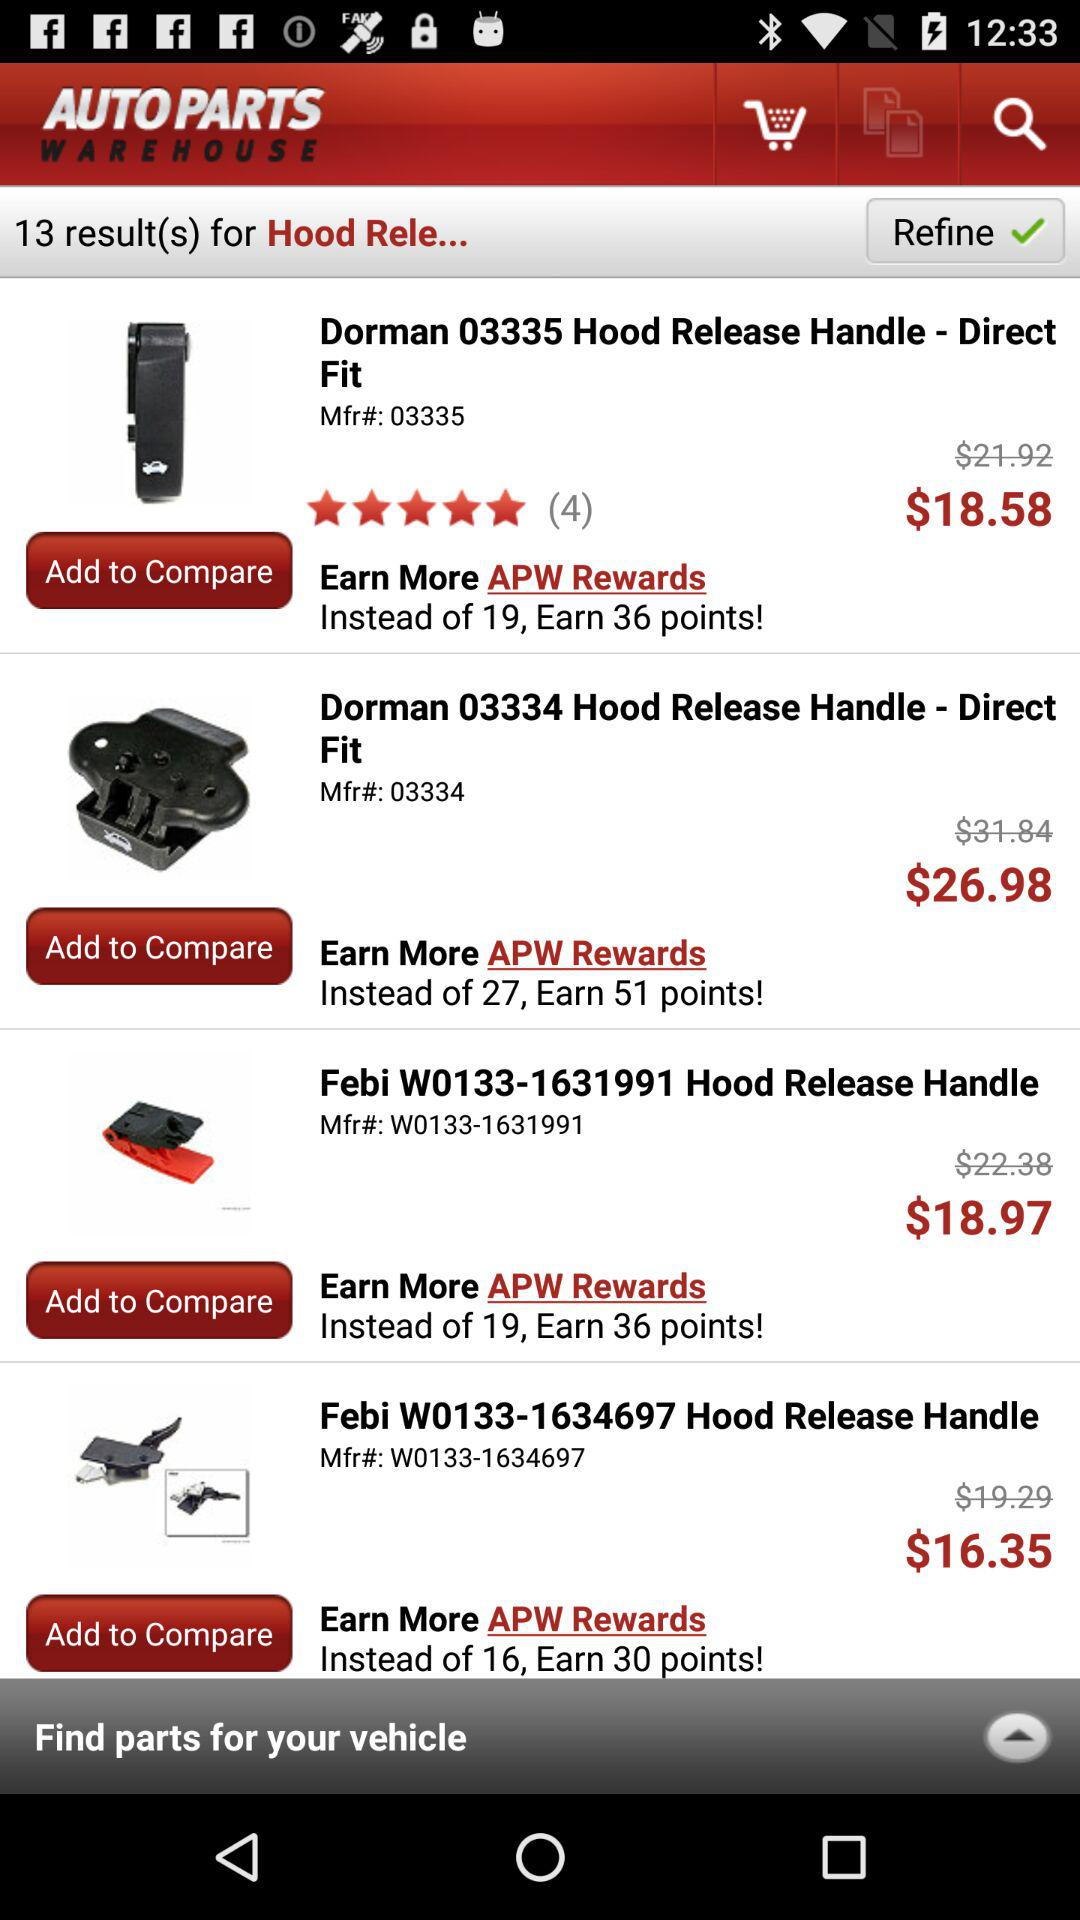What is the price of "Dorman 03334 Hood Release Handle"? The price is $26.98. 